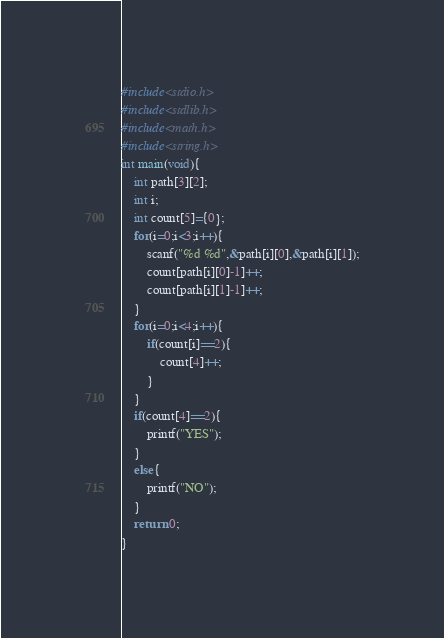Convert code to text. <code><loc_0><loc_0><loc_500><loc_500><_C_>#include<stdio.h>
#include<stdlib.h>
#include<math.h>
#include<string.h>
int main(void){
    int path[3][2];
    int i;
    int count[5]={0};
    for(i=0;i<3;i++){
        scanf("%d %d",&path[i][0],&path[i][1]);
        count[path[i][0]-1]++;
        count[path[i][1]-1]++;
    }
    for(i=0;i<4;i++){
        if(count[i]==2){
            count[4]++;
        }
    }
    if(count[4]==2){
        printf("YES");
    }
    else{
        printf("NO");
    }
    return 0;
}</code> 